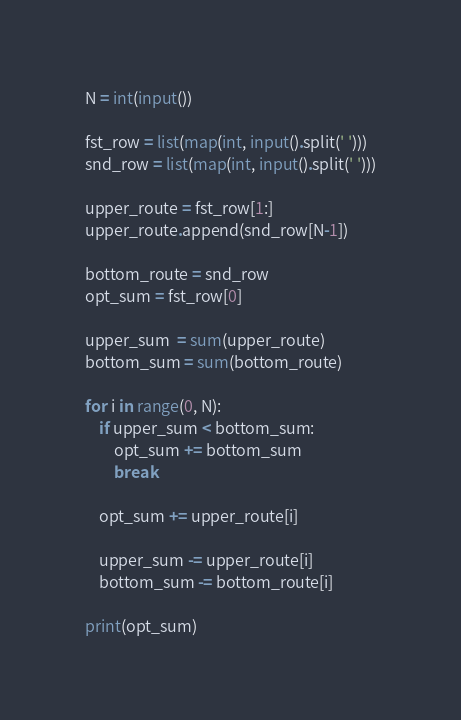Convert code to text. <code><loc_0><loc_0><loc_500><loc_500><_Python_>N = int(input())

fst_row = list(map(int, input().split(' ')))
snd_row = list(map(int, input().split(' ')))

upper_route = fst_row[1:]
upper_route.append(snd_row[N-1])

bottom_route = snd_row
opt_sum = fst_row[0]

upper_sum  = sum(upper_route)
bottom_sum = sum(bottom_route)

for i in range(0, N):
    if upper_sum < bottom_sum:
        opt_sum += bottom_sum
        break
    
    opt_sum += upper_route[i]

    upper_sum -= upper_route[i]
    bottom_sum -= bottom_route[i]

print(opt_sum)
</code> 